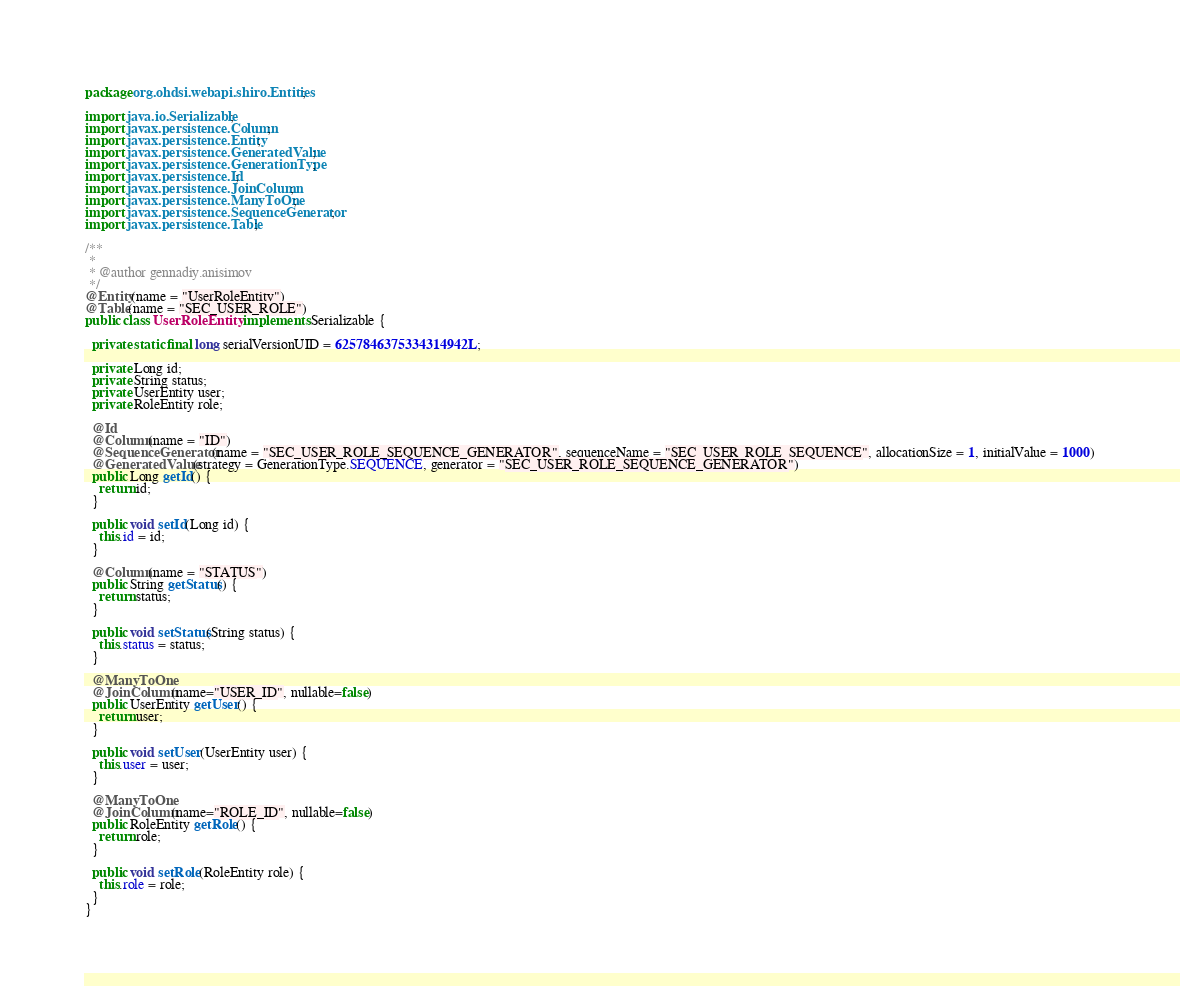Convert code to text. <code><loc_0><loc_0><loc_500><loc_500><_Java_>package org.ohdsi.webapi.shiro.Entities;

import java.io.Serializable;
import javax.persistence.Column;
import javax.persistence.Entity;
import javax.persistence.GeneratedValue;
import javax.persistence.GenerationType;
import javax.persistence.Id;
import javax.persistence.JoinColumn;
import javax.persistence.ManyToOne;
import javax.persistence.SequenceGenerator;
import javax.persistence.Table;

/**
 *
 * @author gennadiy.anisimov
 */
@Entity(name = "UserRoleEntity")
@Table(name = "SEC_USER_ROLE")
public class UserRoleEntity implements Serializable {

  private static final long serialVersionUID = 6257846375334314942L;

  private Long id;
  private String status;
  private UserEntity user;
  private RoleEntity role;

  @Id
  @Column(name = "ID")
  @SequenceGenerator(name = "SEC_USER_ROLE_SEQUENCE_GENERATOR", sequenceName = "SEC_USER_ROLE_SEQUENCE", allocationSize = 1, initialValue = 1000)
  @GeneratedValue(strategy = GenerationType.SEQUENCE, generator = "SEC_USER_ROLE_SEQUENCE_GENERATOR")
  public Long getId() {
    return id;
  }

  public void setId(Long id) {
    this.id = id;
  }

  @Column(name = "STATUS")
  public String getStatus() {
    return status;
  }

  public void setStatus(String status) {
    this.status = status;
  }

  @ManyToOne
  @JoinColumn(name="USER_ID", nullable=false)
  public UserEntity getUser() {
    return user;
  }

  public void setUser(UserEntity user) {
    this.user = user;
  }

  @ManyToOne
  @JoinColumn(name="ROLE_ID", nullable=false)
  public RoleEntity getRole() {
    return role;
  }

  public void setRole(RoleEntity role) {
    this.role = role;
  }
}
</code> 